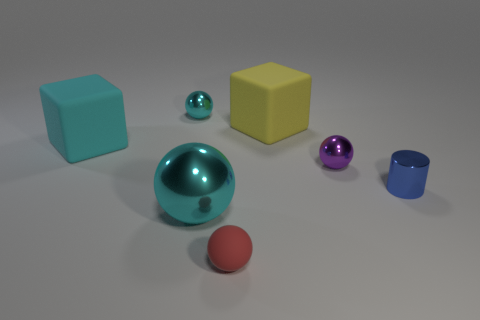What number of tiny things are the same color as the big ball?
Provide a succinct answer. 1. Is the size of the yellow object the same as the cyan thing in front of the cyan matte block?
Your answer should be compact. Yes. What size is the cyan shiny ball that is behind the cyan metallic sphere that is in front of the tiny sphere that is behind the tiny purple ball?
Offer a terse response. Small. How many large objects are on the right side of the cyan cube?
Your answer should be compact. 2. The big object that is left of the shiny thing in front of the blue metal cylinder is made of what material?
Your answer should be very brief. Rubber. Is there any other thing that is the same size as the cyan cube?
Your answer should be compact. Yes. Do the blue object and the cyan rubber block have the same size?
Offer a terse response. No. What number of things are tiny shiny cylinders in front of the big yellow cube or shiny balls to the left of the red ball?
Keep it short and to the point. 3. Is the number of things in front of the big shiny ball greater than the number of large gray metal cylinders?
Your response must be concise. Yes. How many other objects are there of the same shape as the red rubber object?
Provide a short and direct response. 3. 